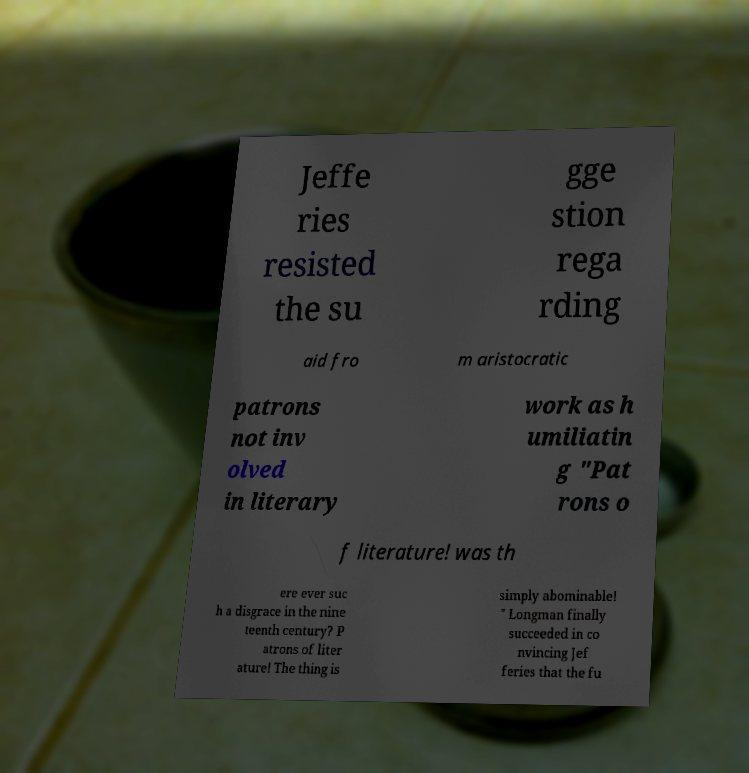What messages or text are displayed in this image? I need them in a readable, typed format. Jeffe ries resisted the su gge stion rega rding aid fro m aristocratic patrons not inv olved in literary work as h umiliatin g "Pat rons o f literature! was th ere ever suc h a disgrace in the nine teenth century? P atrons of liter ature! The thing is simply abominable! " Longman finally succeeded in co nvincing Jef feries that the fu 